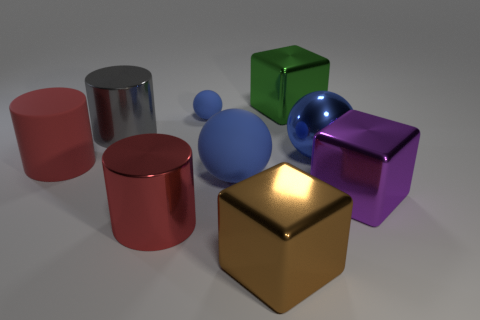What number of things are small blue rubber balls or spheres that are to the right of the big green object?
Offer a very short reply. 2. Is the color of the tiny thing the same as the rubber cylinder?
Give a very brief answer. No. Is there a cylinder made of the same material as the tiny sphere?
Ensure brevity in your answer.  Yes. There is a big rubber object that is the same shape as the gray shiny object; what color is it?
Provide a succinct answer. Red. Does the small thing have the same material as the big object that is to the right of the blue shiny ball?
Ensure brevity in your answer.  No. There is a blue object that is in front of the big sphere that is right of the green block; what shape is it?
Offer a terse response. Sphere. There is a ball right of the brown cube; is it the same size as the red rubber cylinder?
Your response must be concise. Yes. Is the color of the rubber thing to the left of the small blue ball the same as the small object?
Offer a terse response. No. Is there another rubber thing that has the same color as the small rubber thing?
Your answer should be very brief. Yes. What number of brown metallic blocks are right of the green thing?
Your response must be concise. 0. 